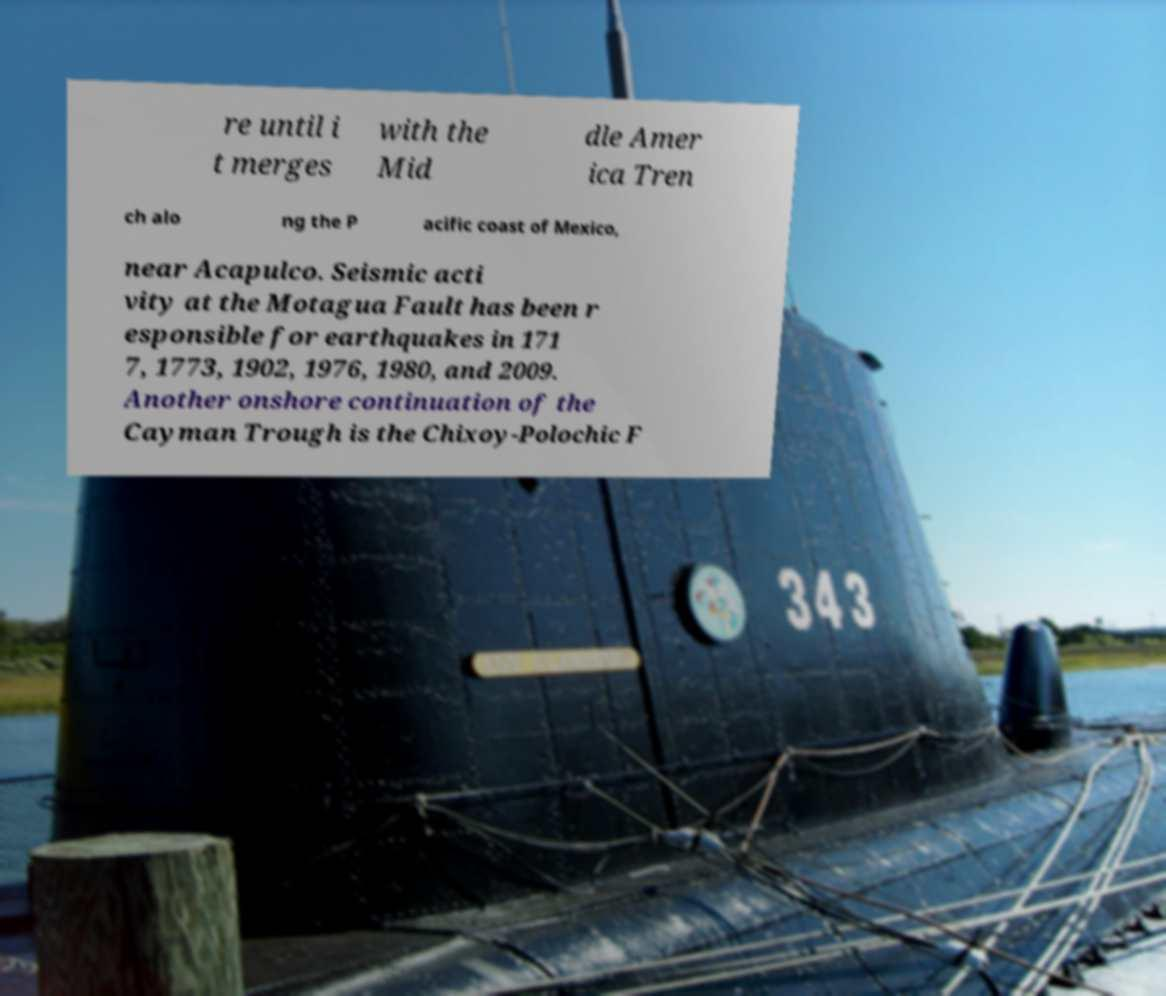There's text embedded in this image that I need extracted. Can you transcribe it verbatim? re until i t merges with the Mid dle Amer ica Tren ch alo ng the P acific coast of Mexico, near Acapulco. Seismic acti vity at the Motagua Fault has been r esponsible for earthquakes in 171 7, 1773, 1902, 1976, 1980, and 2009. Another onshore continuation of the Cayman Trough is the Chixoy-Polochic F 